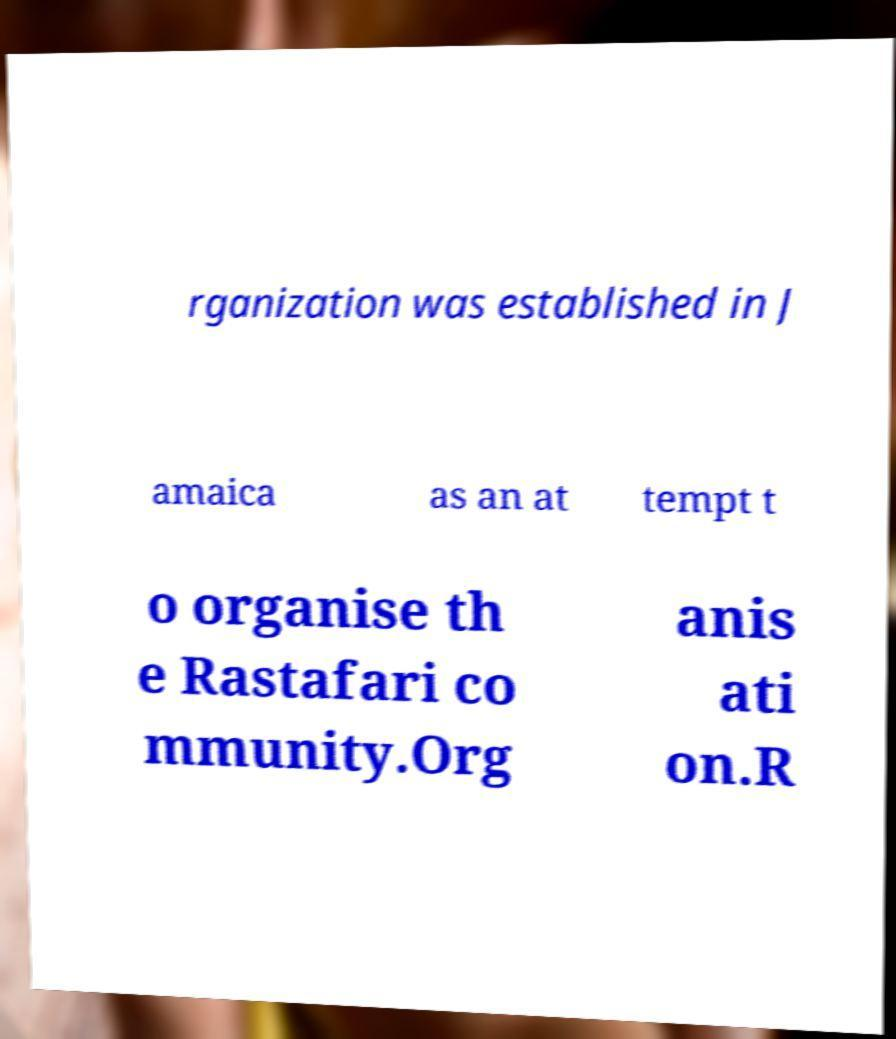There's text embedded in this image that I need extracted. Can you transcribe it verbatim? rganization was established in J amaica as an at tempt t o organise th e Rastafari co mmunity.Org anis ati on.R 